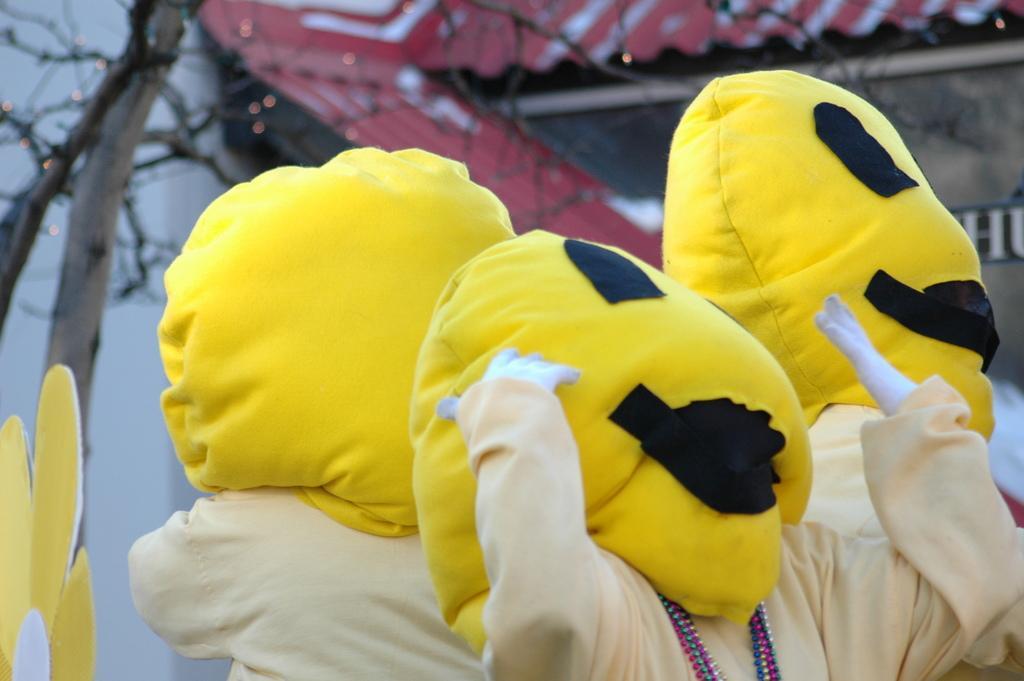Could you give a brief overview of what you see in this image? In this image we can see clowns. In the background there is a shed. On the left we can see a tree. 